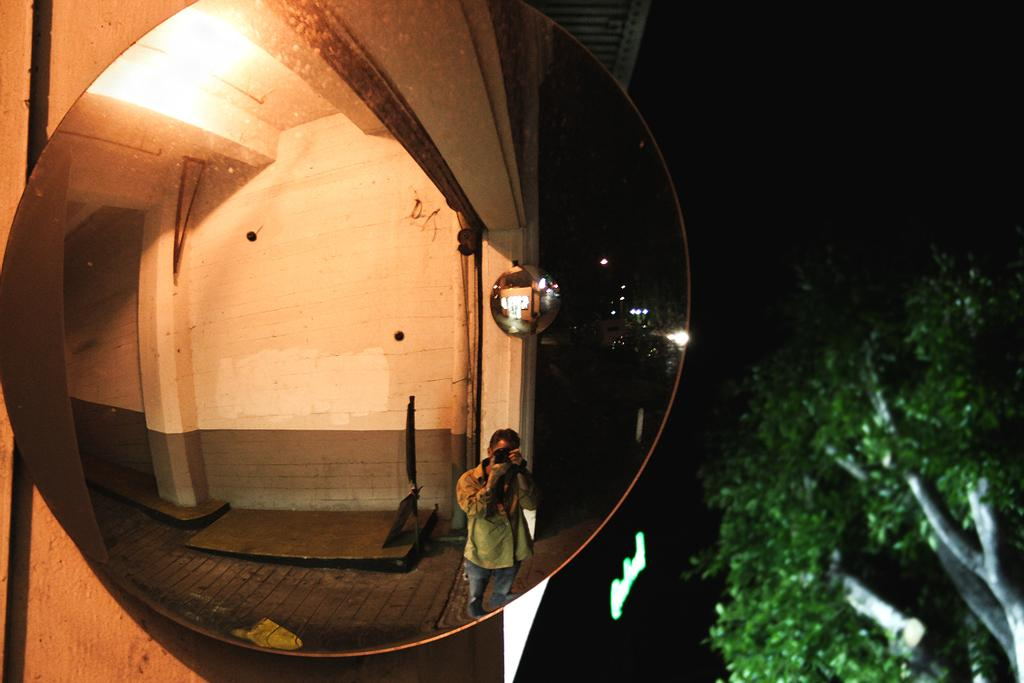What object in the image reflects an image? There is a mirror in the image that reflects a wall. What can be seen in the mirror? A person holding a camera is visible in the mirror. What type of vegetation is on the right side of the image? There is a tree on the right side of the image. What time is displayed on the clocks in the image? There are no clocks present in the image. Can you describe the condition of the frog in the image? There is no frog present in the image. 